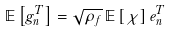<formula> <loc_0><loc_0><loc_500><loc_500>\mathbb { E } \left [ g ^ { T } _ { n } \right ] = \sqrt { \rho _ { f } } \, \mathbb { E } \left [ \chi \right ] e ^ { T } _ { n }</formula> 